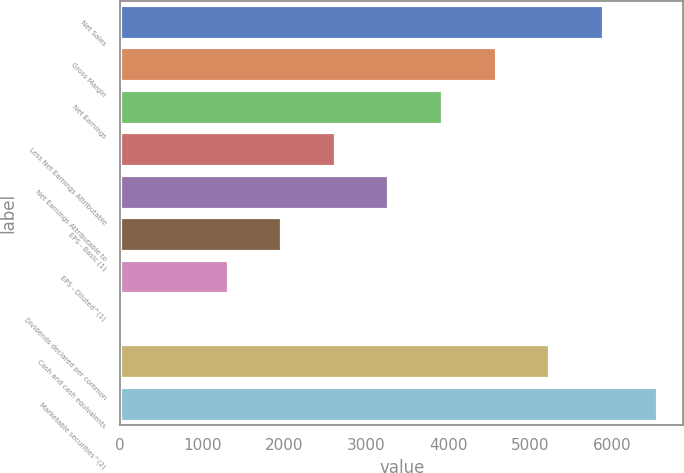<chart> <loc_0><loc_0><loc_500><loc_500><bar_chart><fcel>Net Sales<fcel>Gross Margin<fcel>Net Earnings<fcel>Less Net Earnings Attributable<fcel>Net Earnings Attributable to<fcel>EPS - Basic (1)<fcel>EPS - Diluted^(1)<fcel>Dividends declared per common<fcel>Cash and cash equivalents<fcel>Marketable securities^(2)<nl><fcel>5886.96<fcel>4578.82<fcel>3924.75<fcel>2616.61<fcel>3270.68<fcel>1962.54<fcel>1308.47<fcel>0.33<fcel>5232.89<fcel>6541.03<nl></chart> 